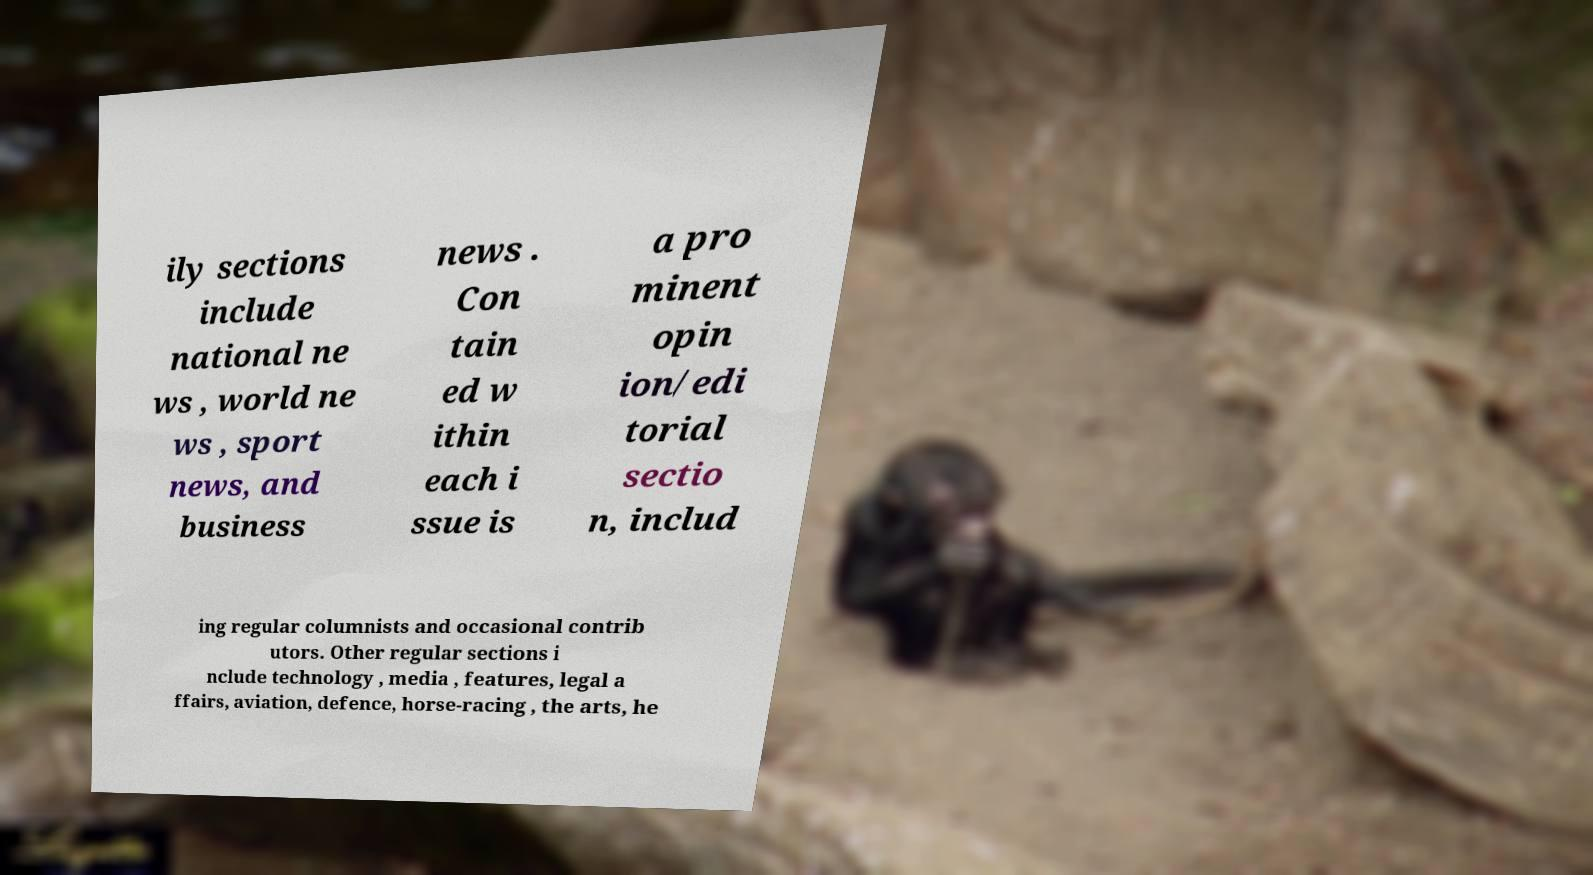What messages or text are displayed in this image? I need them in a readable, typed format. ily sections include national ne ws , world ne ws , sport news, and business news . Con tain ed w ithin each i ssue is a pro minent opin ion/edi torial sectio n, includ ing regular columnists and occasional contrib utors. Other regular sections i nclude technology , media , features, legal a ffairs, aviation, defence, horse-racing , the arts, he 